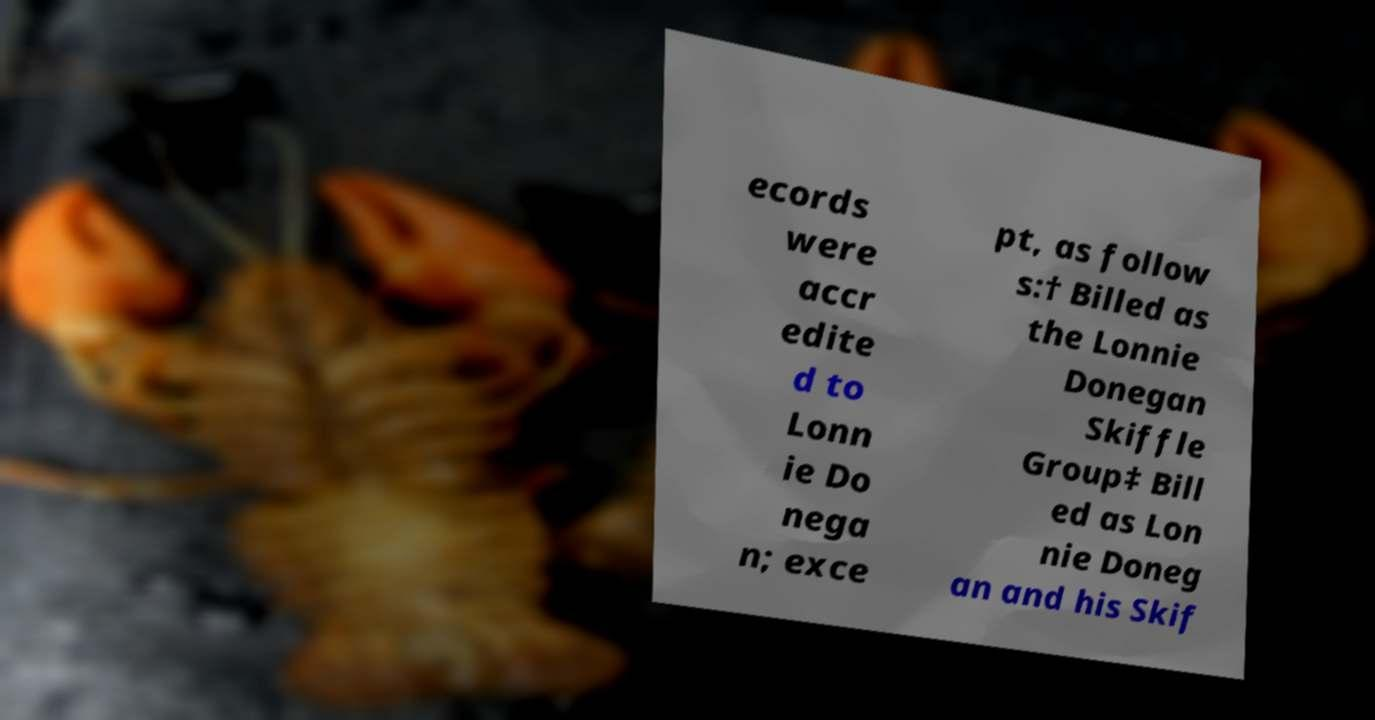There's text embedded in this image that I need extracted. Can you transcribe it verbatim? ecords were accr edite d to Lonn ie Do nega n; exce pt, as follow s:† Billed as the Lonnie Donegan Skiffle Group‡ Bill ed as Lon nie Doneg an and his Skif 